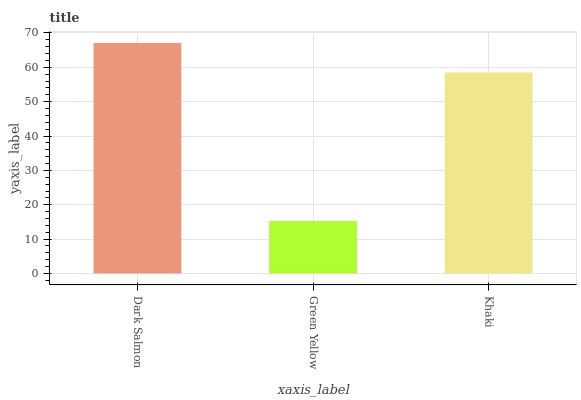Is Green Yellow the minimum?
Answer yes or no. Yes. Is Dark Salmon the maximum?
Answer yes or no. Yes. Is Khaki the minimum?
Answer yes or no. No. Is Khaki the maximum?
Answer yes or no. No. Is Khaki greater than Green Yellow?
Answer yes or no. Yes. Is Green Yellow less than Khaki?
Answer yes or no. Yes. Is Green Yellow greater than Khaki?
Answer yes or no. No. Is Khaki less than Green Yellow?
Answer yes or no. No. Is Khaki the high median?
Answer yes or no. Yes. Is Khaki the low median?
Answer yes or no. Yes. Is Green Yellow the high median?
Answer yes or no. No. Is Dark Salmon the low median?
Answer yes or no. No. 